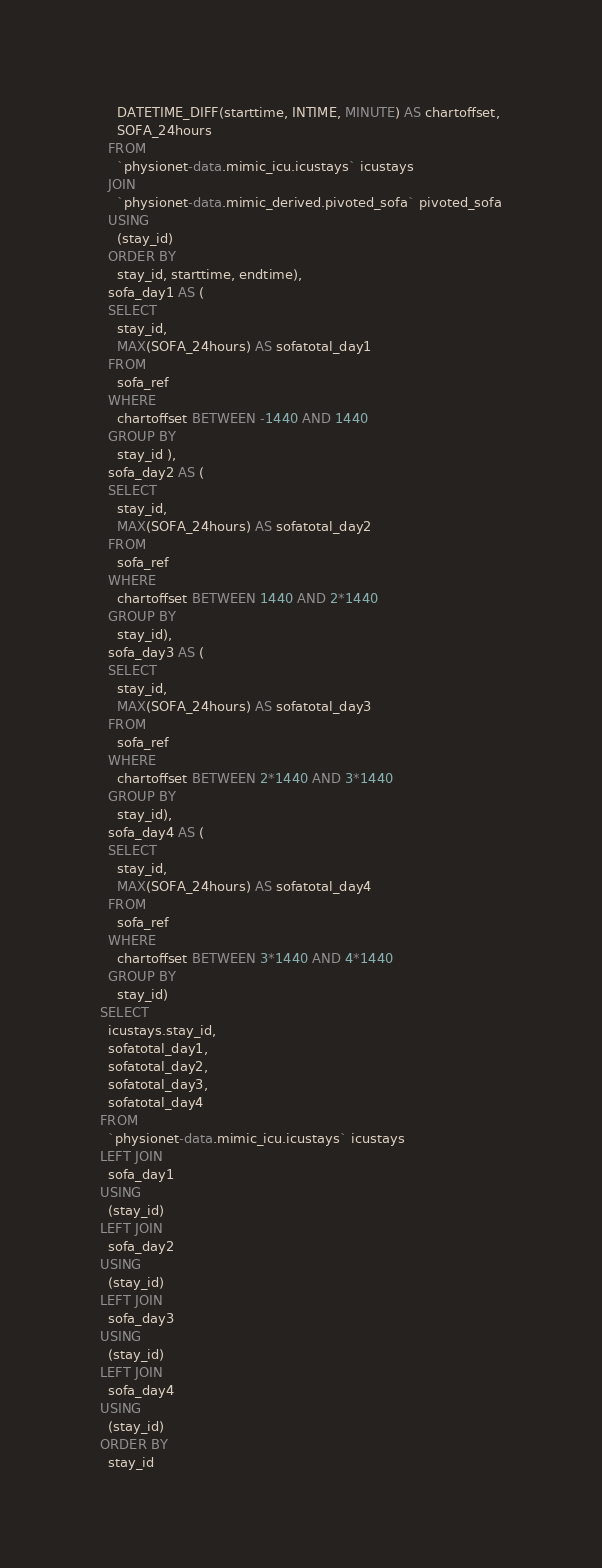<code> <loc_0><loc_0><loc_500><loc_500><_SQL_>    DATETIME_DIFF(starttime, INTIME, MINUTE) AS chartoffset,
    SOFA_24hours
  FROM
    `physionet-data.mimic_icu.icustays` icustays
  JOIN
    `physionet-data.mimic_derived.pivoted_sofa` pivoted_sofa
  USING
    (stay_id)
  ORDER BY
    stay_id, starttime, endtime),
  sofa_day1 AS (
  SELECT
    stay_id,
    MAX(SOFA_24hours) AS sofatotal_day1
  FROM
    sofa_ref
  WHERE
    chartoffset BETWEEN -1440 AND 1440
  GROUP BY
    stay_id ),
  sofa_day2 AS (
  SELECT
    stay_id,
    MAX(SOFA_24hours) AS sofatotal_day2
  FROM
    sofa_ref
  WHERE
    chartoffset BETWEEN 1440 AND 2*1440
  GROUP BY
    stay_id),
  sofa_day3 AS (
  SELECT
    stay_id,
    MAX(SOFA_24hours) AS sofatotal_day3
  FROM
    sofa_ref
  WHERE
    chartoffset BETWEEN 2*1440 AND 3*1440
  GROUP BY
    stay_id),
  sofa_day4 AS (
  SELECT
    stay_id,
    MAX(SOFA_24hours) AS sofatotal_day4
  FROM
    sofa_ref
  WHERE
    chartoffset BETWEEN 3*1440 AND 4*1440
  GROUP BY
    stay_id)
SELECT
  icustays.stay_id,
  sofatotal_day1,
  sofatotal_day2,
  sofatotal_day3,
  sofatotal_day4
FROM
  `physionet-data.mimic_icu.icustays` icustays
LEFT JOIN
  sofa_day1
USING
  (stay_id)
LEFT JOIN
  sofa_day2
USING
  (stay_id)
LEFT JOIN
  sofa_day3
USING
  (stay_id)
LEFT JOIN
  sofa_day4
USING
  (stay_id)  
ORDER BY
  stay_id
</code> 